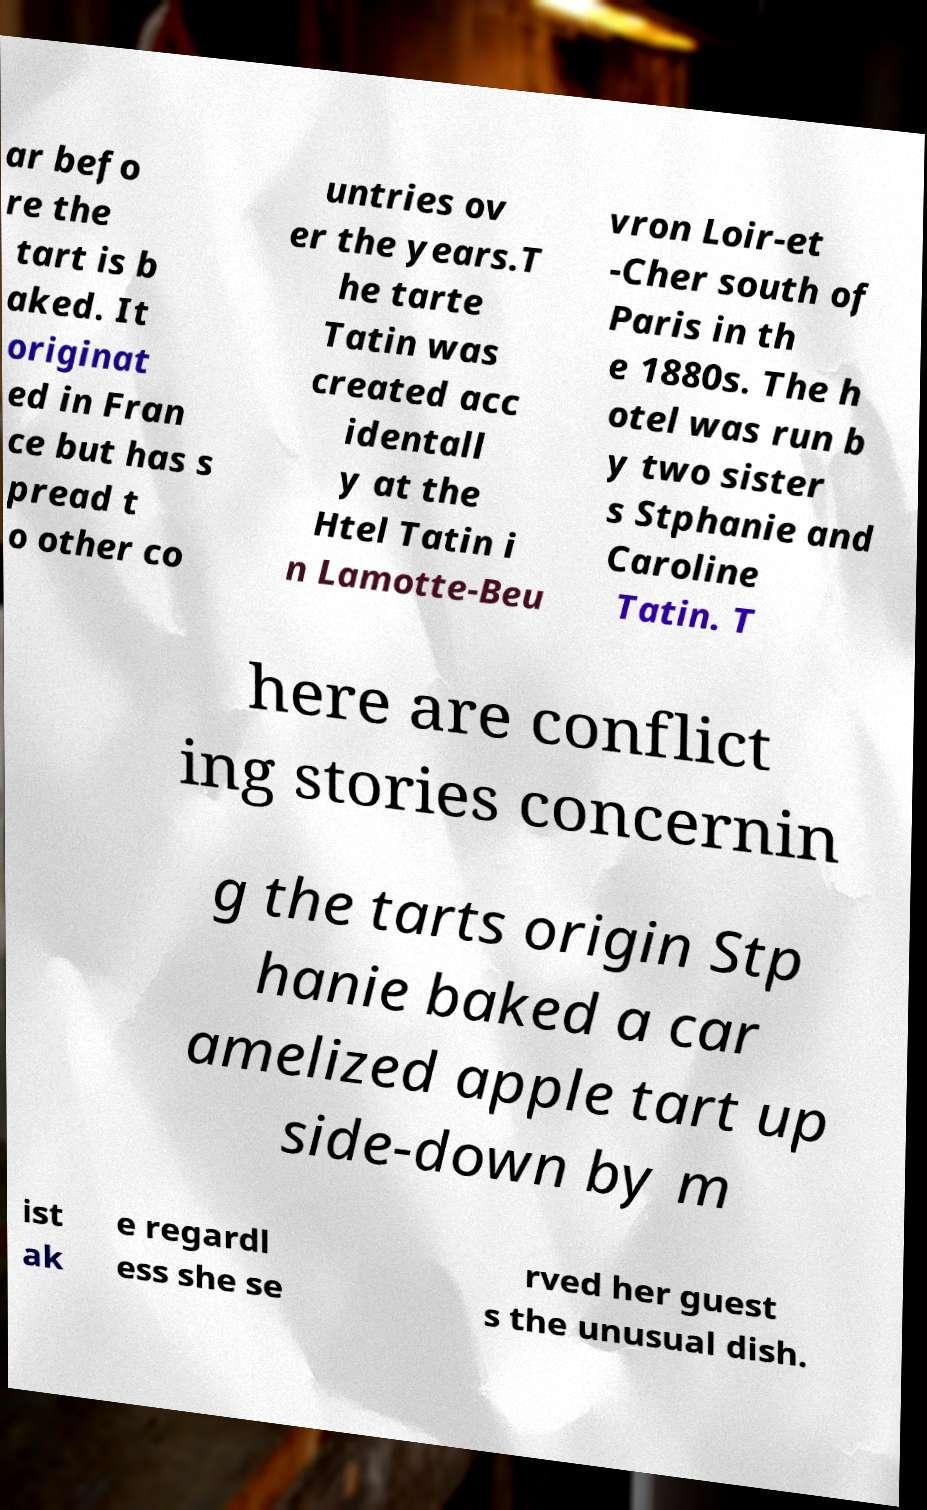Please read and relay the text visible in this image. What does it say? ar befo re the tart is b aked. It originat ed in Fran ce but has s pread t o other co untries ov er the years.T he tarte Tatin was created acc identall y at the Htel Tatin i n Lamotte-Beu vron Loir-et -Cher south of Paris in th e 1880s. The h otel was run b y two sister s Stphanie and Caroline Tatin. T here are conflict ing stories concernin g the tarts origin Stp hanie baked a car amelized apple tart up side-down by m ist ak e regardl ess she se rved her guest s the unusual dish. 